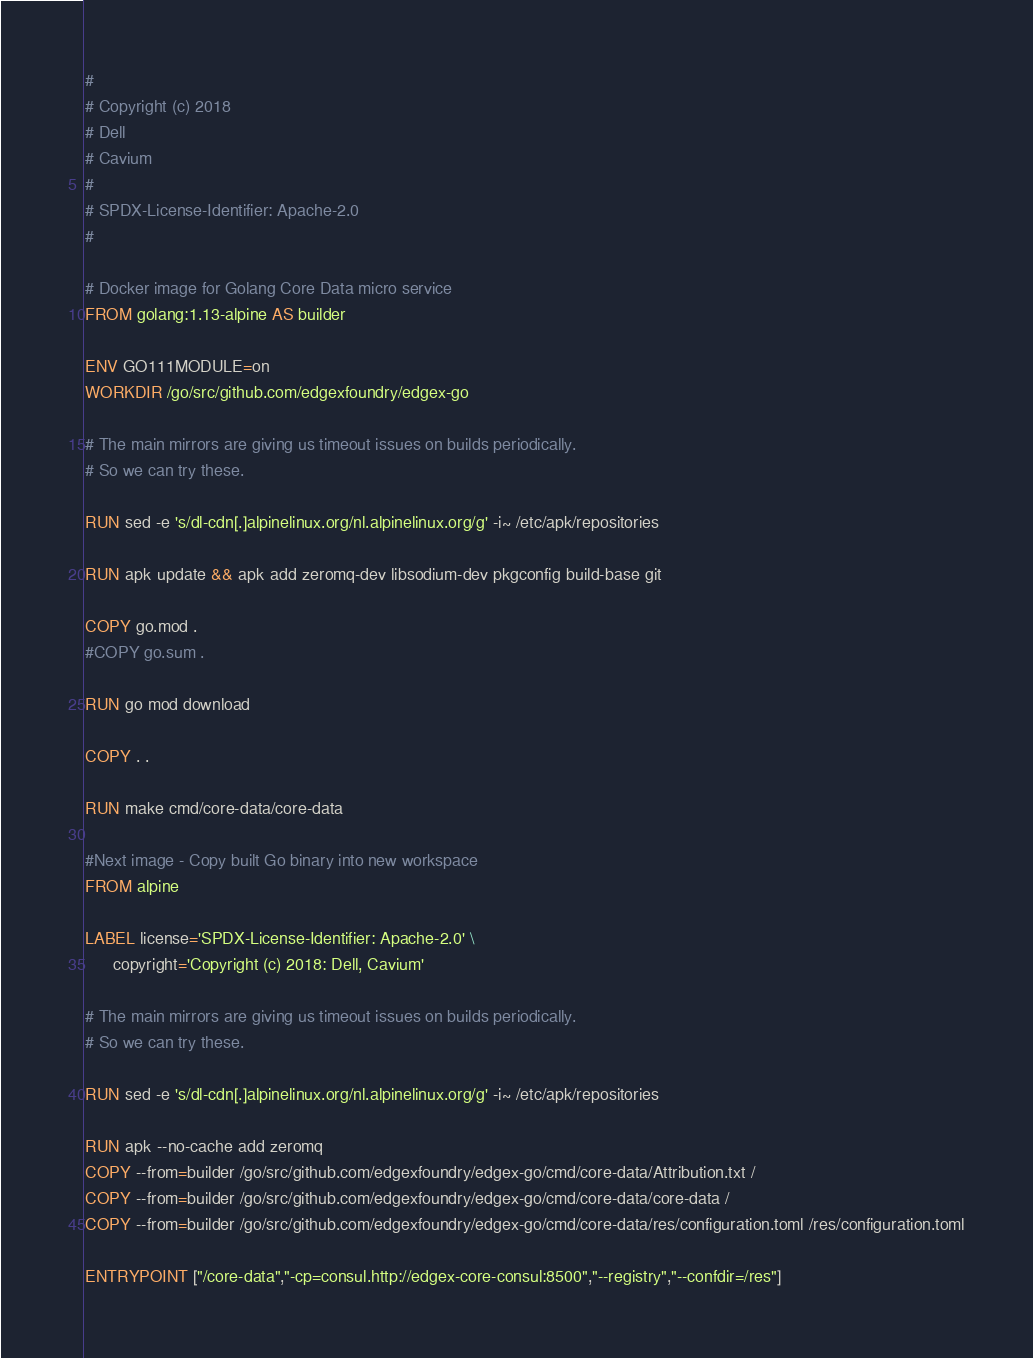Convert code to text. <code><loc_0><loc_0><loc_500><loc_500><_Dockerfile_>#
# Copyright (c) 2018
# Dell
# Cavium
#
# SPDX-License-Identifier: Apache-2.0
#

# Docker image for Golang Core Data micro service 
FROM golang:1.13-alpine AS builder

ENV GO111MODULE=on
WORKDIR /go/src/github.com/edgexfoundry/edgex-go

# The main mirrors are giving us timeout issues on builds periodically.
# So we can try these.

RUN sed -e 's/dl-cdn[.]alpinelinux.org/nl.alpinelinux.org/g' -i~ /etc/apk/repositories

RUN apk update && apk add zeromq-dev libsodium-dev pkgconfig build-base git

COPY go.mod .
#COPY go.sum .

RUN go mod download

COPY . .

RUN make cmd/core-data/core-data

#Next image - Copy built Go binary into new workspace
FROM alpine

LABEL license='SPDX-License-Identifier: Apache-2.0' \
      copyright='Copyright (c) 2018: Dell, Cavium'

# The main mirrors are giving us timeout issues on builds periodically.
# So we can try these.

RUN sed -e 's/dl-cdn[.]alpinelinux.org/nl.alpinelinux.org/g' -i~ /etc/apk/repositories

RUN apk --no-cache add zeromq
COPY --from=builder /go/src/github.com/edgexfoundry/edgex-go/cmd/core-data/Attribution.txt /
COPY --from=builder /go/src/github.com/edgexfoundry/edgex-go/cmd/core-data/core-data /
COPY --from=builder /go/src/github.com/edgexfoundry/edgex-go/cmd/core-data/res/configuration.toml /res/configuration.toml

ENTRYPOINT ["/core-data","-cp=consul.http://edgex-core-consul:8500","--registry","--confdir=/res"]
</code> 